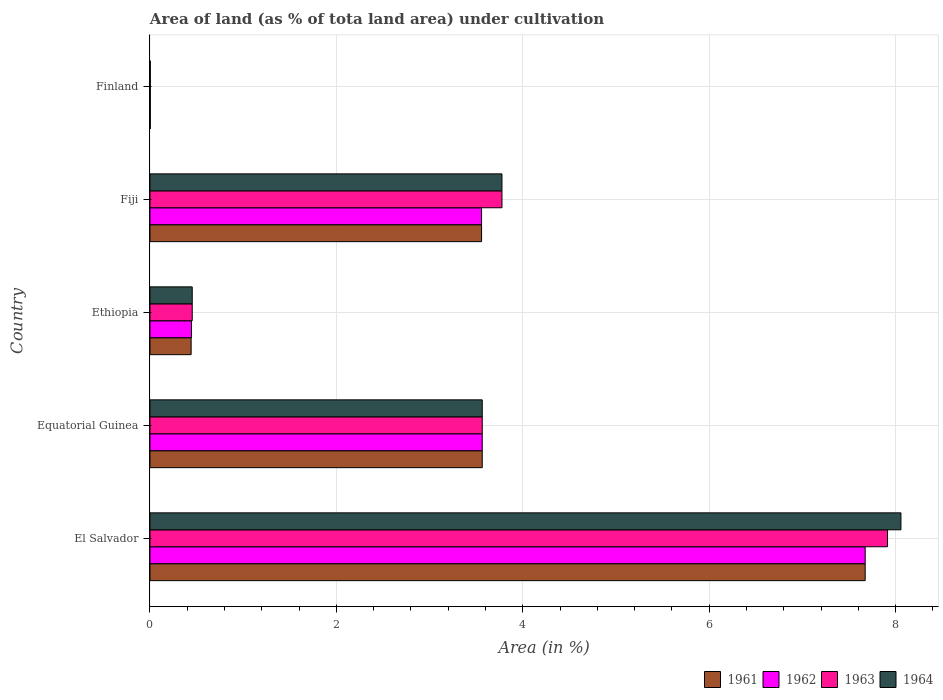Are the number of bars per tick equal to the number of legend labels?
Ensure brevity in your answer.  Yes. What is the label of the 1st group of bars from the top?
Offer a terse response. Finland. What is the percentage of land under cultivation in 1963 in El Salvador?
Make the answer very short. 7.91. Across all countries, what is the maximum percentage of land under cultivation in 1964?
Give a very brief answer. 8.06. Across all countries, what is the minimum percentage of land under cultivation in 1962?
Offer a terse response. 0. In which country was the percentage of land under cultivation in 1961 maximum?
Offer a terse response. El Salvador. In which country was the percentage of land under cultivation in 1961 minimum?
Keep it short and to the point. Finland. What is the total percentage of land under cultivation in 1963 in the graph?
Your response must be concise. 15.71. What is the difference between the percentage of land under cultivation in 1962 in Fiji and that in Finland?
Offer a terse response. 3.55. What is the difference between the percentage of land under cultivation in 1964 in El Salvador and the percentage of land under cultivation in 1961 in Equatorial Guinea?
Give a very brief answer. 4.49. What is the average percentage of land under cultivation in 1963 per country?
Ensure brevity in your answer.  3.14. What is the difference between the percentage of land under cultivation in 1963 and percentage of land under cultivation in 1962 in Equatorial Guinea?
Your answer should be compact. 0. What is the ratio of the percentage of land under cultivation in 1964 in El Salvador to that in Ethiopia?
Provide a succinct answer. 17.78. Is the percentage of land under cultivation in 1964 in El Salvador less than that in Equatorial Guinea?
Keep it short and to the point. No. Is the difference between the percentage of land under cultivation in 1963 in El Salvador and Ethiopia greater than the difference between the percentage of land under cultivation in 1962 in El Salvador and Ethiopia?
Your answer should be very brief. Yes. What is the difference between the highest and the second highest percentage of land under cultivation in 1962?
Your answer should be compact. 4.11. What is the difference between the highest and the lowest percentage of land under cultivation in 1964?
Give a very brief answer. 8.05. In how many countries, is the percentage of land under cultivation in 1961 greater than the average percentage of land under cultivation in 1961 taken over all countries?
Provide a succinct answer. 3. Is the sum of the percentage of land under cultivation in 1961 in Equatorial Guinea and Finland greater than the maximum percentage of land under cultivation in 1964 across all countries?
Offer a very short reply. No. Is it the case that in every country, the sum of the percentage of land under cultivation in 1962 and percentage of land under cultivation in 1961 is greater than the sum of percentage of land under cultivation in 1964 and percentage of land under cultivation in 1963?
Offer a very short reply. No. What does the 2nd bar from the top in Fiji represents?
Provide a short and direct response. 1963. What does the 3rd bar from the bottom in Fiji represents?
Provide a short and direct response. 1963. How many bars are there?
Your answer should be compact. 20. How many countries are there in the graph?
Your response must be concise. 5. Does the graph contain grids?
Make the answer very short. Yes. Where does the legend appear in the graph?
Provide a short and direct response. Bottom right. How are the legend labels stacked?
Offer a terse response. Horizontal. What is the title of the graph?
Provide a succinct answer. Area of land (as % of tota land area) under cultivation. What is the label or title of the X-axis?
Provide a short and direct response. Area (in %). What is the Area (in %) of 1961 in El Salvador?
Your answer should be compact. 7.67. What is the Area (in %) in 1962 in El Salvador?
Offer a terse response. 7.67. What is the Area (in %) of 1963 in El Salvador?
Offer a terse response. 7.91. What is the Area (in %) in 1964 in El Salvador?
Your answer should be very brief. 8.06. What is the Area (in %) in 1961 in Equatorial Guinea?
Keep it short and to the point. 3.57. What is the Area (in %) of 1962 in Equatorial Guinea?
Your answer should be very brief. 3.57. What is the Area (in %) in 1963 in Equatorial Guinea?
Give a very brief answer. 3.57. What is the Area (in %) in 1964 in Equatorial Guinea?
Provide a succinct answer. 3.57. What is the Area (in %) of 1961 in Ethiopia?
Provide a short and direct response. 0.44. What is the Area (in %) of 1962 in Ethiopia?
Keep it short and to the point. 0.45. What is the Area (in %) of 1963 in Ethiopia?
Give a very brief answer. 0.45. What is the Area (in %) of 1964 in Ethiopia?
Offer a terse response. 0.45. What is the Area (in %) of 1961 in Fiji?
Make the answer very short. 3.56. What is the Area (in %) in 1962 in Fiji?
Keep it short and to the point. 3.56. What is the Area (in %) in 1963 in Fiji?
Keep it short and to the point. 3.78. What is the Area (in %) of 1964 in Fiji?
Your answer should be compact. 3.78. What is the Area (in %) in 1961 in Finland?
Keep it short and to the point. 0. What is the Area (in %) in 1962 in Finland?
Keep it short and to the point. 0. What is the Area (in %) of 1963 in Finland?
Provide a succinct answer. 0. What is the Area (in %) in 1964 in Finland?
Make the answer very short. 0. Across all countries, what is the maximum Area (in %) in 1961?
Provide a succinct answer. 7.67. Across all countries, what is the maximum Area (in %) of 1962?
Provide a short and direct response. 7.67. Across all countries, what is the maximum Area (in %) in 1963?
Your response must be concise. 7.91. Across all countries, what is the maximum Area (in %) in 1964?
Provide a succinct answer. 8.06. Across all countries, what is the minimum Area (in %) in 1961?
Provide a short and direct response. 0. Across all countries, what is the minimum Area (in %) of 1962?
Provide a succinct answer. 0. Across all countries, what is the minimum Area (in %) of 1963?
Your answer should be very brief. 0. Across all countries, what is the minimum Area (in %) of 1964?
Ensure brevity in your answer.  0. What is the total Area (in %) in 1961 in the graph?
Offer a very short reply. 15.24. What is the total Area (in %) of 1962 in the graph?
Give a very brief answer. 15.24. What is the total Area (in %) of 1963 in the graph?
Provide a succinct answer. 15.71. What is the total Area (in %) of 1964 in the graph?
Offer a terse response. 15.86. What is the difference between the Area (in %) of 1961 in El Salvador and that in Equatorial Guinea?
Your answer should be compact. 4.11. What is the difference between the Area (in %) of 1962 in El Salvador and that in Equatorial Guinea?
Keep it short and to the point. 4.11. What is the difference between the Area (in %) in 1963 in El Salvador and that in Equatorial Guinea?
Provide a short and direct response. 4.35. What is the difference between the Area (in %) in 1964 in El Salvador and that in Equatorial Guinea?
Your answer should be very brief. 4.49. What is the difference between the Area (in %) of 1961 in El Salvador and that in Ethiopia?
Make the answer very short. 7.23. What is the difference between the Area (in %) in 1962 in El Salvador and that in Ethiopia?
Your answer should be very brief. 7.23. What is the difference between the Area (in %) in 1963 in El Salvador and that in Ethiopia?
Offer a very short reply. 7.46. What is the difference between the Area (in %) of 1964 in El Salvador and that in Ethiopia?
Give a very brief answer. 7.6. What is the difference between the Area (in %) in 1961 in El Salvador and that in Fiji?
Your answer should be compact. 4.12. What is the difference between the Area (in %) of 1962 in El Salvador and that in Fiji?
Your answer should be very brief. 4.12. What is the difference between the Area (in %) of 1963 in El Salvador and that in Fiji?
Your response must be concise. 4.14. What is the difference between the Area (in %) of 1964 in El Salvador and that in Fiji?
Your response must be concise. 4.28. What is the difference between the Area (in %) of 1961 in El Salvador and that in Finland?
Provide a short and direct response. 7.67. What is the difference between the Area (in %) of 1962 in El Salvador and that in Finland?
Ensure brevity in your answer.  7.67. What is the difference between the Area (in %) in 1963 in El Salvador and that in Finland?
Offer a terse response. 7.91. What is the difference between the Area (in %) of 1964 in El Salvador and that in Finland?
Your answer should be very brief. 8.05. What is the difference between the Area (in %) of 1961 in Equatorial Guinea and that in Ethiopia?
Provide a short and direct response. 3.12. What is the difference between the Area (in %) in 1962 in Equatorial Guinea and that in Ethiopia?
Keep it short and to the point. 3.12. What is the difference between the Area (in %) in 1963 in Equatorial Guinea and that in Ethiopia?
Your answer should be very brief. 3.11. What is the difference between the Area (in %) in 1964 in Equatorial Guinea and that in Ethiopia?
Your answer should be very brief. 3.11. What is the difference between the Area (in %) in 1961 in Equatorial Guinea and that in Fiji?
Your response must be concise. 0.01. What is the difference between the Area (in %) in 1962 in Equatorial Guinea and that in Fiji?
Offer a very short reply. 0.01. What is the difference between the Area (in %) of 1963 in Equatorial Guinea and that in Fiji?
Provide a succinct answer. -0.21. What is the difference between the Area (in %) of 1964 in Equatorial Guinea and that in Fiji?
Provide a succinct answer. -0.21. What is the difference between the Area (in %) in 1961 in Equatorial Guinea and that in Finland?
Keep it short and to the point. 3.56. What is the difference between the Area (in %) of 1962 in Equatorial Guinea and that in Finland?
Offer a terse response. 3.56. What is the difference between the Area (in %) of 1963 in Equatorial Guinea and that in Finland?
Make the answer very short. 3.56. What is the difference between the Area (in %) in 1964 in Equatorial Guinea and that in Finland?
Ensure brevity in your answer.  3.56. What is the difference between the Area (in %) of 1961 in Ethiopia and that in Fiji?
Offer a very short reply. -3.12. What is the difference between the Area (in %) in 1962 in Ethiopia and that in Fiji?
Give a very brief answer. -3.11. What is the difference between the Area (in %) in 1963 in Ethiopia and that in Fiji?
Give a very brief answer. -3.32. What is the difference between the Area (in %) of 1964 in Ethiopia and that in Fiji?
Provide a short and direct response. -3.32. What is the difference between the Area (in %) in 1961 in Ethiopia and that in Finland?
Ensure brevity in your answer.  0.44. What is the difference between the Area (in %) of 1962 in Ethiopia and that in Finland?
Provide a succinct answer. 0.44. What is the difference between the Area (in %) in 1963 in Ethiopia and that in Finland?
Keep it short and to the point. 0.45. What is the difference between the Area (in %) in 1964 in Ethiopia and that in Finland?
Make the answer very short. 0.45. What is the difference between the Area (in %) of 1961 in Fiji and that in Finland?
Your answer should be very brief. 3.55. What is the difference between the Area (in %) in 1962 in Fiji and that in Finland?
Your answer should be very brief. 3.55. What is the difference between the Area (in %) of 1963 in Fiji and that in Finland?
Make the answer very short. 3.77. What is the difference between the Area (in %) of 1964 in Fiji and that in Finland?
Give a very brief answer. 3.77. What is the difference between the Area (in %) in 1961 in El Salvador and the Area (in %) in 1962 in Equatorial Guinea?
Offer a terse response. 4.11. What is the difference between the Area (in %) in 1961 in El Salvador and the Area (in %) in 1963 in Equatorial Guinea?
Keep it short and to the point. 4.11. What is the difference between the Area (in %) of 1961 in El Salvador and the Area (in %) of 1964 in Equatorial Guinea?
Ensure brevity in your answer.  4.11. What is the difference between the Area (in %) of 1962 in El Salvador and the Area (in %) of 1963 in Equatorial Guinea?
Provide a succinct answer. 4.11. What is the difference between the Area (in %) of 1962 in El Salvador and the Area (in %) of 1964 in Equatorial Guinea?
Your answer should be compact. 4.11. What is the difference between the Area (in %) of 1963 in El Salvador and the Area (in %) of 1964 in Equatorial Guinea?
Provide a short and direct response. 4.35. What is the difference between the Area (in %) of 1961 in El Salvador and the Area (in %) of 1962 in Ethiopia?
Offer a terse response. 7.23. What is the difference between the Area (in %) of 1961 in El Salvador and the Area (in %) of 1963 in Ethiopia?
Provide a short and direct response. 7.22. What is the difference between the Area (in %) of 1961 in El Salvador and the Area (in %) of 1964 in Ethiopia?
Your answer should be compact. 7.22. What is the difference between the Area (in %) in 1962 in El Salvador and the Area (in %) in 1963 in Ethiopia?
Your answer should be compact. 7.22. What is the difference between the Area (in %) in 1962 in El Salvador and the Area (in %) in 1964 in Ethiopia?
Ensure brevity in your answer.  7.22. What is the difference between the Area (in %) of 1963 in El Salvador and the Area (in %) of 1964 in Ethiopia?
Provide a succinct answer. 7.46. What is the difference between the Area (in %) in 1961 in El Salvador and the Area (in %) in 1962 in Fiji?
Provide a short and direct response. 4.12. What is the difference between the Area (in %) of 1961 in El Salvador and the Area (in %) of 1963 in Fiji?
Ensure brevity in your answer.  3.9. What is the difference between the Area (in %) in 1961 in El Salvador and the Area (in %) in 1964 in Fiji?
Keep it short and to the point. 3.9. What is the difference between the Area (in %) in 1962 in El Salvador and the Area (in %) in 1963 in Fiji?
Your answer should be very brief. 3.9. What is the difference between the Area (in %) of 1962 in El Salvador and the Area (in %) of 1964 in Fiji?
Ensure brevity in your answer.  3.9. What is the difference between the Area (in %) of 1963 in El Salvador and the Area (in %) of 1964 in Fiji?
Give a very brief answer. 4.14. What is the difference between the Area (in %) in 1961 in El Salvador and the Area (in %) in 1962 in Finland?
Your answer should be very brief. 7.67. What is the difference between the Area (in %) of 1961 in El Salvador and the Area (in %) of 1963 in Finland?
Give a very brief answer. 7.67. What is the difference between the Area (in %) in 1961 in El Salvador and the Area (in %) in 1964 in Finland?
Offer a very short reply. 7.67. What is the difference between the Area (in %) in 1962 in El Salvador and the Area (in %) in 1963 in Finland?
Your response must be concise. 7.67. What is the difference between the Area (in %) of 1962 in El Salvador and the Area (in %) of 1964 in Finland?
Provide a short and direct response. 7.67. What is the difference between the Area (in %) in 1963 in El Salvador and the Area (in %) in 1964 in Finland?
Offer a very short reply. 7.91. What is the difference between the Area (in %) of 1961 in Equatorial Guinea and the Area (in %) of 1962 in Ethiopia?
Ensure brevity in your answer.  3.12. What is the difference between the Area (in %) of 1961 in Equatorial Guinea and the Area (in %) of 1963 in Ethiopia?
Give a very brief answer. 3.11. What is the difference between the Area (in %) of 1961 in Equatorial Guinea and the Area (in %) of 1964 in Ethiopia?
Ensure brevity in your answer.  3.11. What is the difference between the Area (in %) in 1962 in Equatorial Guinea and the Area (in %) in 1963 in Ethiopia?
Offer a very short reply. 3.11. What is the difference between the Area (in %) of 1962 in Equatorial Guinea and the Area (in %) of 1964 in Ethiopia?
Your answer should be very brief. 3.11. What is the difference between the Area (in %) in 1963 in Equatorial Guinea and the Area (in %) in 1964 in Ethiopia?
Offer a very short reply. 3.11. What is the difference between the Area (in %) of 1961 in Equatorial Guinea and the Area (in %) of 1962 in Fiji?
Your answer should be compact. 0.01. What is the difference between the Area (in %) of 1961 in Equatorial Guinea and the Area (in %) of 1963 in Fiji?
Offer a terse response. -0.21. What is the difference between the Area (in %) in 1961 in Equatorial Guinea and the Area (in %) in 1964 in Fiji?
Your answer should be compact. -0.21. What is the difference between the Area (in %) of 1962 in Equatorial Guinea and the Area (in %) of 1963 in Fiji?
Your response must be concise. -0.21. What is the difference between the Area (in %) in 1962 in Equatorial Guinea and the Area (in %) in 1964 in Fiji?
Provide a short and direct response. -0.21. What is the difference between the Area (in %) of 1963 in Equatorial Guinea and the Area (in %) of 1964 in Fiji?
Make the answer very short. -0.21. What is the difference between the Area (in %) in 1961 in Equatorial Guinea and the Area (in %) in 1962 in Finland?
Ensure brevity in your answer.  3.56. What is the difference between the Area (in %) of 1961 in Equatorial Guinea and the Area (in %) of 1963 in Finland?
Keep it short and to the point. 3.56. What is the difference between the Area (in %) of 1961 in Equatorial Guinea and the Area (in %) of 1964 in Finland?
Give a very brief answer. 3.56. What is the difference between the Area (in %) in 1962 in Equatorial Guinea and the Area (in %) in 1963 in Finland?
Provide a short and direct response. 3.56. What is the difference between the Area (in %) in 1962 in Equatorial Guinea and the Area (in %) in 1964 in Finland?
Provide a short and direct response. 3.56. What is the difference between the Area (in %) in 1963 in Equatorial Guinea and the Area (in %) in 1964 in Finland?
Offer a very short reply. 3.56. What is the difference between the Area (in %) of 1961 in Ethiopia and the Area (in %) of 1962 in Fiji?
Provide a short and direct response. -3.12. What is the difference between the Area (in %) of 1961 in Ethiopia and the Area (in %) of 1963 in Fiji?
Make the answer very short. -3.34. What is the difference between the Area (in %) in 1961 in Ethiopia and the Area (in %) in 1964 in Fiji?
Give a very brief answer. -3.34. What is the difference between the Area (in %) in 1962 in Ethiopia and the Area (in %) in 1963 in Fiji?
Give a very brief answer. -3.33. What is the difference between the Area (in %) in 1962 in Ethiopia and the Area (in %) in 1964 in Fiji?
Ensure brevity in your answer.  -3.33. What is the difference between the Area (in %) of 1963 in Ethiopia and the Area (in %) of 1964 in Fiji?
Your answer should be very brief. -3.32. What is the difference between the Area (in %) in 1961 in Ethiopia and the Area (in %) in 1962 in Finland?
Ensure brevity in your answer.  0.44. What is the difference between the Area (in %) in 1961 in Ethiopia and the Area (in %) in 1963 in Finland?
Provide a succinct answer. 0.44. What is the difference between the Area (in %) in 1961 in Ethiopia and the Area (in %) in 1964 in Finland?
Provide a succinct answer. 0.44. What is the difference between the Area (in %) of 1962 in Ethiopia and the Area (in %) of 1963 in Finland?
Make the answer very short. 0.44. What is the difference between the Area (in %) of 1962 in Ethiopia and the Area (in %) of 1964 in Finland?
Make the answer very short. 0.44. What is the difference between the Area (in %) in 1963 in Ethiopia and the Area (in %) in 1964 in Finland?
Keep it short and to the point. 0.45. What is the difference between the Area (in %) in 1961 in Fiji and the Area (in %) in 1962 in Finland?
Your answer should be compact. 3.55. What is the difference between the Area (in %) of 1961 in Fiji and the Area (in %) of 1963 in Finland?
Keep it short and to the point. 3.55. What is the difference between the Area (in %) in 1961 in Fiji and the Area (in %) in 1964 in Finland?
Make the answer very short. 3.55. What is the difference between the Area (in %) of 1962 in Fiji and the Area (in %) of 1963 in Finland?
Keep it short and to the point. 3.55. What is the difference between the Area (in %) of 1962 in Fiji and the Area (in %) of 1964 in Finland?
Make the answer very short. 3.55. What is the difference between the Area (in %) in 1963 in Fiji and the Area (in %) in 1964 in Finland?
Provide a succinct answer. 3.77. What is the average Area (in %) in 1961 per country?
Give a very brief answer. 3.05. What is the average Area (in %) in 1962 per country?
Keep it short and to the point. 3.05. What is the average Area (in %) in 1963 per country?
Ensure brevity in your answer.  3.14. What is the average Area (in %) of 1964 per country?
Keep it short and to the point. 3.17. What is the difference between the Area (in %) in 1961 and Area (in %) in 1962 in El Salvador?
Provide a succinct answer. 0. What is the difference between the Area (in %) of 1961 and Area (in %) of 1963 in El Salvador?
Your response must be concise. -0.24. What is the difference between the Area (in %) in 1961 and Area (in %) in 1964 in El Salvador?
Provide a succinct answer. -0.38. What is the difference between the Area (in %) of 1962 and Area (in %) of 1963 in El Salvador?
Give a very brief answer. -0.24. What is the difference between the Area (in %) in 1962 and Area (in %) in 1964 in El Salvador?
Ensure brevity in your answer.  -0.38. What is the difference between the Area (in %) of 1963 and Area (in %) of 1964 in El Salvador?
Keep it short and to the point. -0.14. What is the difference between the Area (in %) of 1961 and Area (in %) of 1962 in Equatorial Guinea?
Provide a succinct answer. 0. What is the difference between the Area (in %) of 1961 and Area (in %) of 1963 in Equatorial Guinea?
Provide a short and direct response. 0. What is the difference between the Area (in %) of 1962 and Area (in %) of 1963 in Equatorial Guinea?
Your answer should be compact. 0. What is the difference between the Area (in %) in 1962 and Area (in %) in 1964 in Equatorial Guinea?
Your answer should be compact. 0. What is the difference between the Area (in %) in 1963 and Area (in %) in 1964 in Equatorial Guinea?
Give a very brief answer. 0. What is the difference between the Area (in %) in 1961 and Area (in %) in 1962 in Ethiopia?
Your answer should be very brief. -0. What is the difference between the Area (in %) of 1961 and Area (in %) of 1963 in Ethiopia?
Provide a short and direct response. -0.01. What is the difference between the Area (in %) of 1961 and Area (in %) of 1964 in Ethiopia?
Provide a succinct answer. -0.01. What is the difference between the Area (in %) in 1962 and Area (in %) in 1963 in Ethiopia?
Ensure brevity in your answer.  -0.01. What is the difference between the Area (in %) in 1962 and Area (in %) in 1964 in Ethiopia?
Make the answer very short. -0.01. What is the difference between the Area (in %) of 1963 and Area (in %) of 1964 in Ethiopia?
Keep it short and to the point. 0. What is the difference between the Area (in %) of 1961 and Area (in %) of 1962 in Fiji?
Give a very brief answer. 0. What is the difference between the Area (in %) in 1961 and Area (in %) in 1963 in Fiji?
Your response must be concise. -0.22. What is the difference between the Area (in %) in 1961 and Area (in %) in 1964 in Fiji?
Offer a terse response. -0.22. What is the difference between the Area (in %) of 1962 and Area (in %) of 1963 in Fiji?
Keep it short and to the point. -0.22. What is the difference between the Area (in %) in 1962 and Area (in %) in 1964 in Fiji?
Your answer should be compact. -0.22. What is the difference between the Area (in %) in 1963 and Area (in %) in 1964 in Fiji?
Give a very brief answer. 0. What is the difference between the Area (in %) of 1961 and Area (in %) of 1962 in Finland?
Ensure brevity in your answer.  0. What is the difference between the Area (in %) of 1961 and Area (in %) of 1963 in Finland?
Your answer should be compact. 0. What is the difference between the Area (in %) of 1961 and Area (in %) of 1964 in Finland?
Keep it short and to the point. 0. What is the ratio of the Area (in %) in 1961 in El Salvador to that in Equatorial Guinea?
Offer a terse response. 2.15. What is the ratio of the Area (in %) in 1962 in El Salvador to that in Equatorial Guinea?
Keep it short and to the point. 2.15. What is the ratio of the Area (in %) in 1963 in El Salvador to that in Equatorial Guinea?
Your answer should be compact. 2.22. What is the ratio of the Area (in %) of 1964 in El Salvador to that in Equatorial Guinea?
Offer a terse response. 2.26. What is the ratio of the Area (in %) in 1961 in El Salvador to that in Ethiopia?
Offer a terse response. 17.38. What is the ratio of the Area (in %) of 1962 in El Salvador to that in Ethiopia?
Your answer should be compact. 17.24. What is the ratio of the Area (in %) of 1963 in El Salvador to that in Ethiopia?
Your answer should be very brief. 17.46. What is the ratio of the Area (in %) in 1964 in El Salvador to that in Ethiopia?
Your response must be concise. 17.78. What is the ratio of the Area (in %) in 1961 in El Salvador to that in Fiji?
Give a very brief answer. 2.16. What is the ratio of the Area (in %) in 1962 in El Salvador to that in Fiji?
Your answer should be compact. 2.16. What is the ratio of the Area (in %) in 1963 in El Salvador to that in Fiji?
Provide a short and direct response. 2.1. What is the ratio of the Area (in %) of 1964 in El Salvador to that in Fiji?
Give a very brief answer. 2.13. What is the ratio of the Area (in %) in 1961 in El Salvador to that in Finland?
Offer a very short reply. 2337.38. What is the ratio of the Area (in %) in 1962 in El Salvador to that in Finland?
Your response must be concise. 2337.38. What is the ratio of the Area (in %) in 1963 in El Salvador to that in Finland?
Your answer should be very brief. 2410.42. What is the ratio of the Area (in %) in 1964 in El Salvador to that in Finland?
Ensure brevity in your answer.  2454.25. What is the ratio of the Area (in %) in 1961 in Equatorial Guinea to that in Ethiopia?
Offer a very short reply. 8.08. What is the ratio of the Area (in %) in 1962 in Equatorial Guinea to that in Ethiopia?
Ensure brevity in your answer.  8.01. What is the ratio of the Area (in %) in 1963 in Equatorial Guinea to that in Ethiopia?
Your answer should be compact. 7.87. What is the ratio of the Area (in %) of 1964 in Equatorial Guinea to that in Ethiopia?
Ensure brevity in your answer.  7.87. What is the ratio of the Area (in %) of 1961 in Equatorial Guinea to that in Fiji?
Give a very brief answer. 1. What is the ratio of the Area (in %) of 1962 in Equatorial Guinea to that in Fiji?
Keep it short and to the point. 1. What is the ratio of the Area (in %) of 1963 in Equatorial Guinea to that in Fiji?
Offer a terse response. 0.94. What is the ratio of the Area (in %) of 1964 in Equatorial Guinea to that in Fiji?
Offer a terse response. 0.94. What is the ratio of the Area (in %) of 1961 in Equatorial Guinea to that in Finland?
Provide a short and direct response. 1085.88. What is the ratio of the Area (in %) in 1962 in Equatorial Guinea to that in Finland?
Your answer should be very brief. 1085.88. What is the ratio of the Area (in %) in 1963 in Equatorial Guinea to that in Finland?
Your answer should be compact. 1085.88. What is the ratio of the Area (in %) of 1964 in Equatorial Guinea to that in Finland?
Provide a short and direct response. 1085.88. What is the ratio of the Area (in %) of 1961 in Ethiopia to that in Fiji?
Make the answer very short. 0.12. What is the ratio of the Area (in %) in 1962 in Ethiopia to that in Fiji?
Your answer should be compact. 0.13. What is the ratio of the Area (in %) of 1963 in Ethiopia to that in Fiji?
Ensure brevity in your answer.  0.12. What is the ratio of the Area (in %) of 1964 in Ethiopia to that in Fiji?
Give a very brief answer. 0.12. What is the ratio of the Area (in %) of 1961 in Ethiopia to that in Finland?
Ensure brevity in your answer.  134.45. What is the ratio of the Area (in %) of 1962 in Ethiopia to that in Finland?
Offer a very short reply. 135.56. What is the ratio of the Area (in %) of 1963 in Ethiopia to that in Finland?
Your response must be concise. 138.05. What is the ratio of the Area (in %) of 1964 in Ethiopia to that in Finland?
Your answer should be very brief. 138.05. What is the ratio of the Area (in %) in 1961 in Fiji to that in Finland?
Your answer should be compact. 1083.65. What is the ratio of the Area (in %) of 1962 in Fiji to that in Finland?
Offer a terse response. 1083.65. What is the ratio of the Area (in %) in 1963 in Fiji to that in Finland?
Offer a very short reply. 1150.34. What is the ratio of the Area (in %) of 1964 in Fiji to that in Finland?
Give a very brief answer. 1150.34. What is the difference between the highest and the second highest Area (in %) in 1961?
Your answer should be compact. 4.11. What is the difference between the highest and the second highest Area (in %) of 1962?
Provide a short and direct response. 4.11. What is the difference between the highest and the second highest Area (in %) of 1963?
Your answer should be compact. 4.14. What is the difference between the highest and the second highest Area (in %) of 1964?
Give a very brief answer. 4.28. What is the difference between the highest and the lowest Area (in %) in 1961?
Your answer should be compact. 7.67. What is the difference between the highest and the lowest Area (in %) in 1962?
Give a very brief answer. 7.67. What is the difference between the highest and the lowest Area (in %) of 1963?
Your response must be concise. 7.91. What is the difference between the highest and the lowest Area (in %) in 1964?
Give a very brief answer. 8.05. 